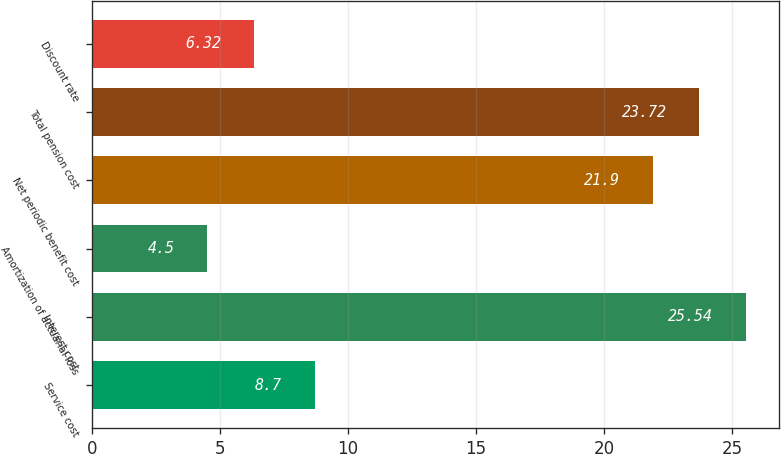Convert chart. <chart><loc_0><loc_0><loc_500><loc_500><bar_chart><fcel>Service cost<fcel>Interest cost<fcel>Amortization of actuarial loss<fcel>Net periodic benefit cost<fcel>Total pension cost<fcel>Discount rate<nl><fcel>8.7<fcel>25.54<fcel>4.5<fcel>21.9<fcel>23.72<fcel>6.32<nl></chart> 